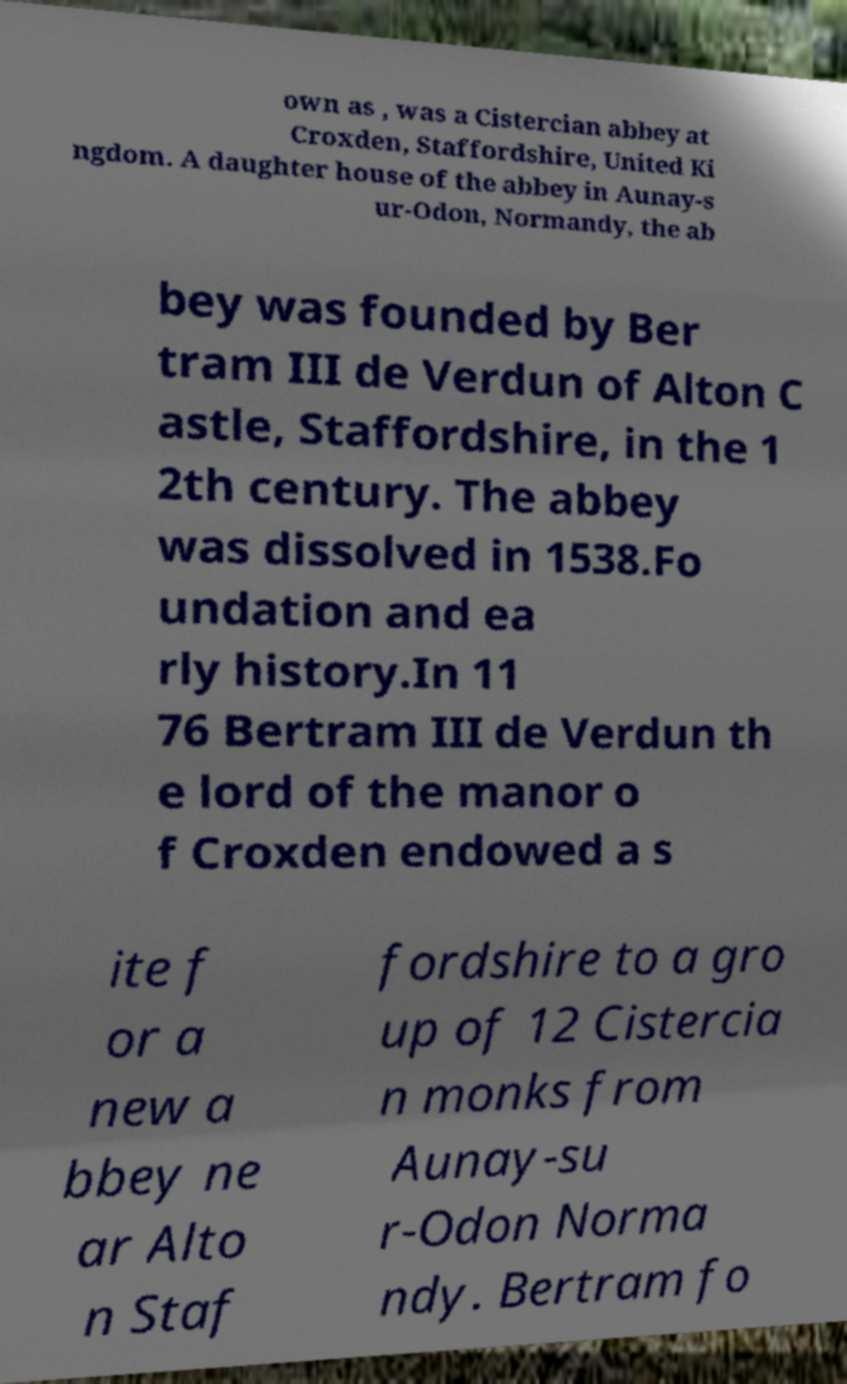Could you extract and type out the text from this image? own as , was a Cistercian abbey at Croxden, Staffordshire, United Ki ngdom. A daughter house of the abbey in Aunay-s ur-Odon, Normandy, the ab bey was founded by Ber tram III de Verdun of Alton C astle, Staffordshire, in the 1 2th century. The abbey was dissolved in 1538.Fo undation and ea rly history.In 11 76 Bertram III de Verdun th e lord of the manor o f Croxden endowed a s ite f or a new a bbey ne ar Alto n Staf fordshire to a gro up of 12 Cistercia n monks from Aunay-su r-Odon Norma ndy. Bertram fo 